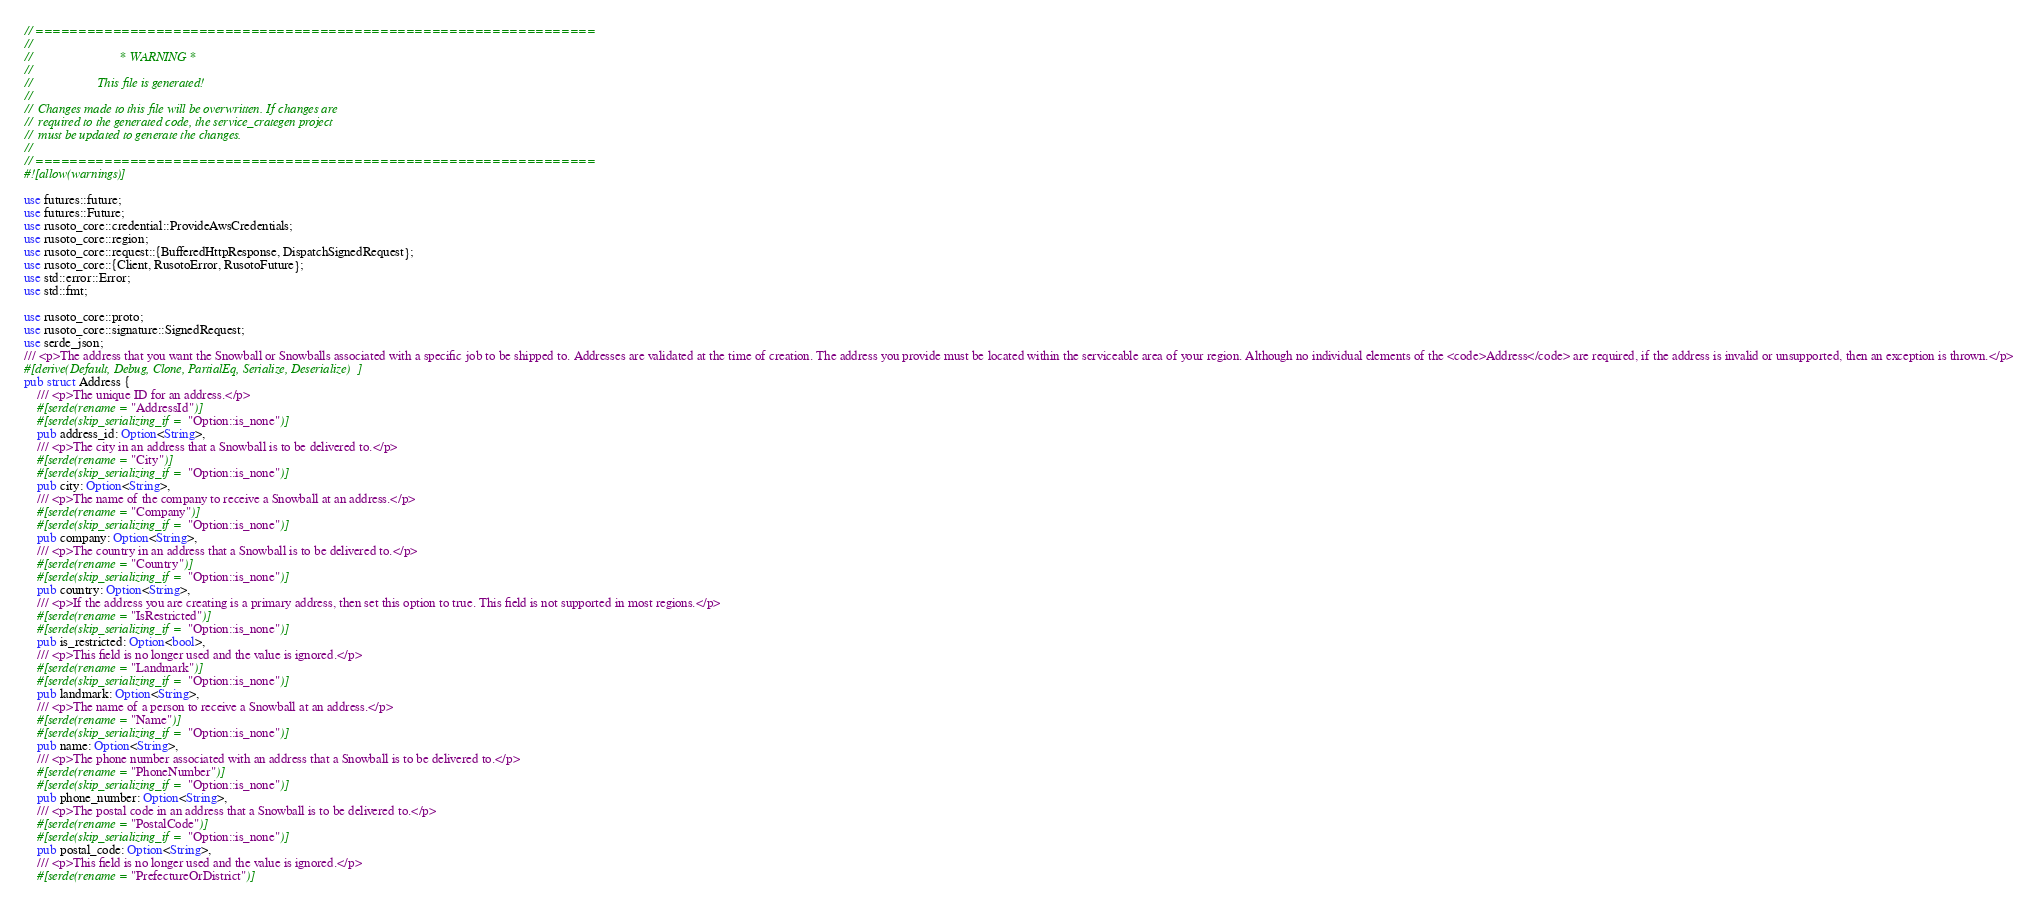Convert code to text. <code><loc_0><loc_0><loc_500><loc_500><_Rust_>// =================================================================
//
//                           * WARNING *
//
//                    This file is generated!
//
//  Changes made to this file will be overwritten. If changes are
//  required to the generated code, the service_crategen project
//  must be updated to generate the changes.
//
// =================================================================
#![allow(warnings)]

use futures::future;
use futures::Future;
use rusoto_core::credential::ProvideAwsCredentials;
use rusoto_core::region;
use rusoto_core::request::{BufferedHttpResponse, DispatchSignedRequest};
use rusoto_core::{Client, RusotoError, RusotoFuture};
use std::error::Error;
use std::fmt;

use rusoto_core::proto;
use rusoto_core::signature::SignedRequest;
use serde_json;
/// <p>The address that you want the Snowball or Snowballs associated with a specific job to be shipped to. Addresses are validated at the time of creation. The address you provide must be located within the serviceable area of your region. Although no individual elements of the <code>Address</code> are required, if the address is invalid or unsupported, then an exception is thrown.</p>
#[derive(Default, Debug, Clone, PartialEq, Serialize, Deserialize)]
pub struct Address {
    /// <p>The unique ID for an address.</p>
    #[serde(rename = "AddressId")]
    #[serde(skip_serializing_if = "Option::is_none")]
    pub address_id: Option<String>,
    /// <p>The city in an address that a Snowball is to be delivered to.</p>
    #[serde(rename = "City")]
    #[serde(skip_serializing_if = "Option::is_none")]
    pub city: Option<String>,
    /// <p>The name of the company to receive a Snowball at an address.</p>
    #[serde(rename = "Company")]
    #[serde(skip_serializing_if = "Option::is_none")]
    pub company: Option<String>,
    /// <p>The country in an address that a Snowball is to be delivered to.</p>
    #[serde(rename = "Country")]
    #[serde(skip_serializing_if = "Option::is_none")]
    pub country: Option<String>,
    /// <p>If the address you are creating is a primary address, then set this option to true. This field is not supported in most regions.</p>
    #[serde(rename = "IsRestricted")]
    #[serde(skip_serializing_if = "Option::is_none")]
    pub is_restricted: Option<bool>,
    /// <p>This field is no longer used and the value is ignored.</p>
    #[serde(rename = "Landmark")]
    #[serde(skip_serializing_if = "Option::is_none")]
    pub landmark: Option<String>,
    /// <p>The name of a person to receive a Snowball at an address.</p>
    #[serde(rename = "Name")]
    #[serde(skip_serializing_if = "Option::is_none")]
    pub name: Option<String>,
    /// <p>The phone number associated with an address that a Snowball is to be delivered to.</p>
    #[serde(rename = "PhoneNumber")]
    #[serde(skip_serializing_if = "Option::is_none")]
    pub phone_number: Option<String>,
    /// <p>The postal code in an address that a Snowball is to be delivered to.</p>
    #[serde(rename = "PostalCode")]
    #[serde(skip_serializing_if = "Option::is_none")]
    pub postal_code: Option<String>,
    /// <p>This field is no longer used and the value is ignored.</p>
    #[serde(rename = "PrefectureOrDistrict")]</code> 